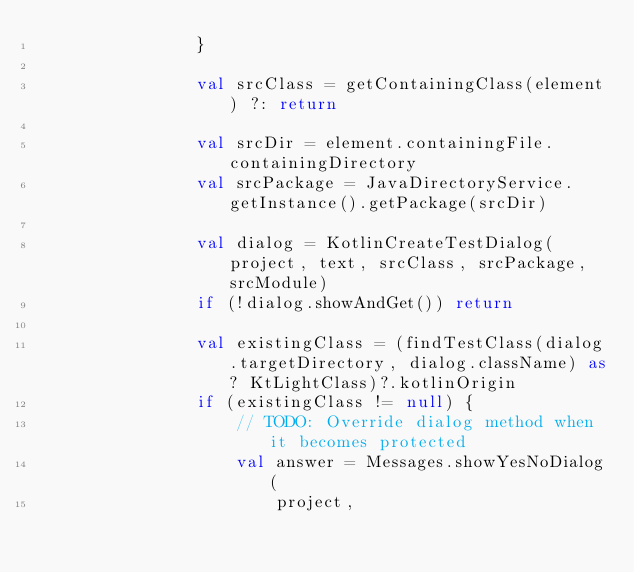Convert code to text. <code><loc_0><loc_0><loc_500><loc_500><_Kotlin_>                }

                val srcClass = getContainingClass(element) ?: return

                val srcDir = element.containingFile.containingDirectory
                val srcPackage = JavaDirectoryService.getInstance().getPackage(srcDir)

                val dialog = KotlinCreateTestDialog(project, text, srcClass, srcPackage, srcModule)
                if (!dialog.showAndGet()) return

                val existingClass = (findTestClass(dialog.targetDirectory, dialog.className) as? KtLightClass)?.kotlinOrigin
                if (existingClass != null) {
                    // TODO: Override dialog method when it becomes protected
                    val answer = Messages.showYesNoDialog(
                        project,</code> 